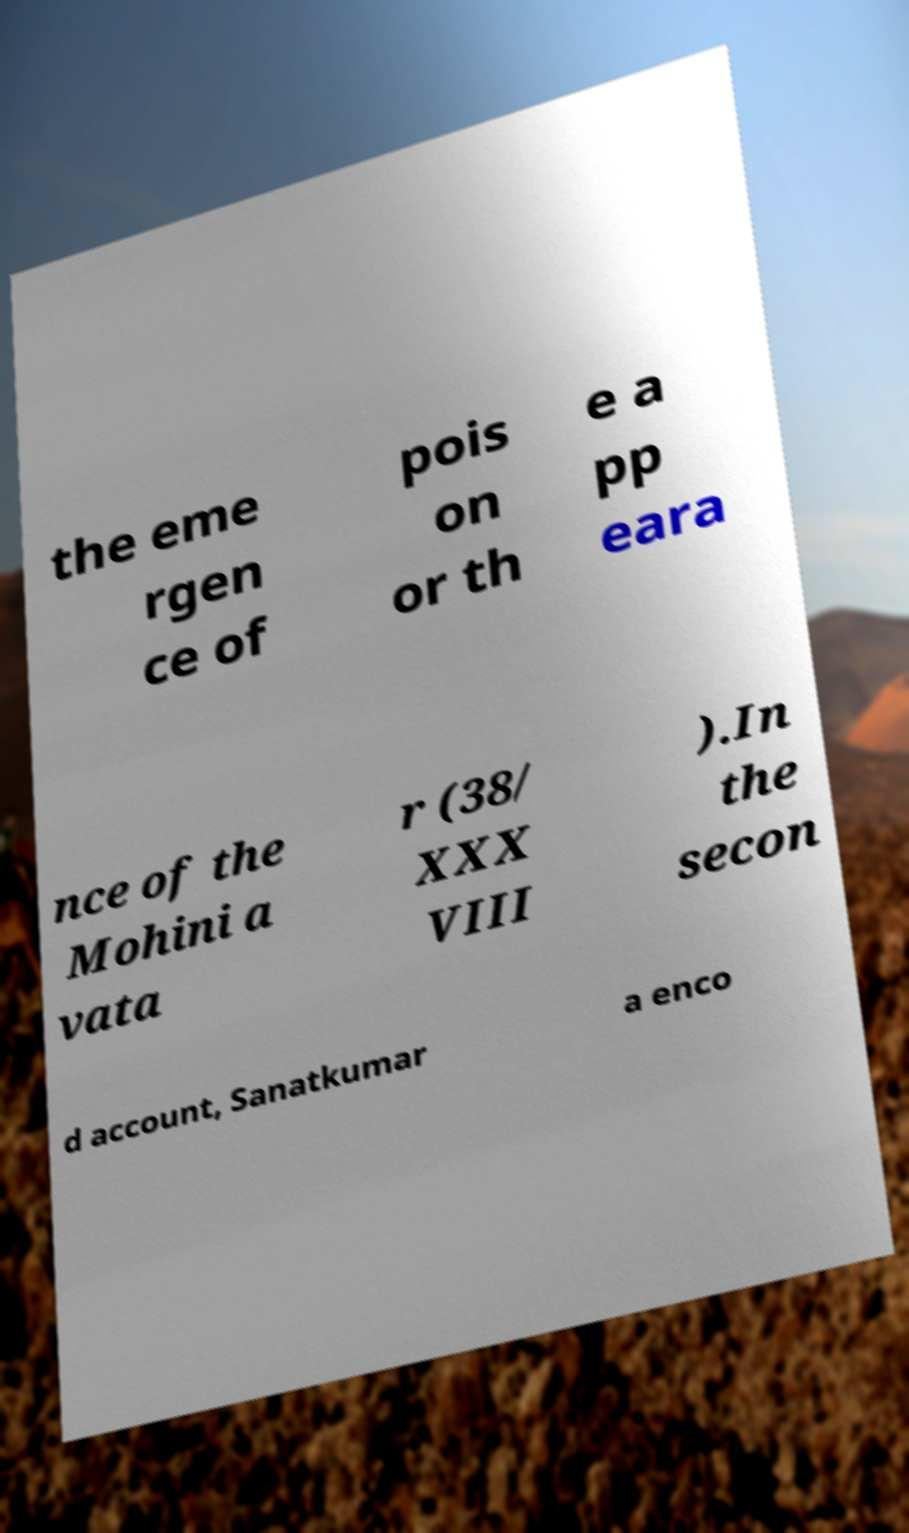What messages or text are displayed in this image? I need them in a readable, typed format. the eme rgen ce of pois on or th e a pp eara nce of the Mohini a vata r (38/ XXX VIII ).In the secon d account, Sanatkumar a enco 